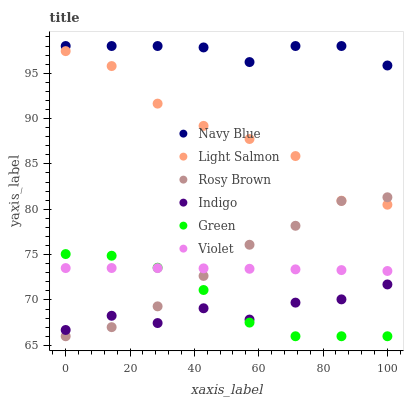Does Indigo have the minimum area under the curve?
Answer yes or no. Yes. Does Navy Blue have the maximum area under the curve?
Answer yes or no. Yes. Does Navy Blue have the minimum area under the curve?
Answer yes or no. No. Does Indigo have the maximum area under the curve?
Answer yes or no. No. Is Violet the smoothest?
Answer yes or no. Yes. Is Indigo the roughest?
Answer yes or no. Yes. Is Navy Blue the smoothest?
Answer yes or no. No. Is Navy Blue the roughest?
Answer yes or no. No. Does Rosy Brown have the lowest value?
Answer yes or no. Yes. Does Indigo have the lowest value?
Answer yes or no. No. Does Navy Blue have the highest value?
Answer yes or no. Yes. Does Indigo have the highest value?
Answer yes or no. No. Is Indigo less than Light Salmon?
Answer yes or no. Yes. Is Light Salmon greater than Violet?
Answer yes or no. Yes. Does Green intersect Indigo?
Answer yes or no. Yes. Is Green less than Indigo?
Answer yes or no. No. Is Green greater than Indigo?
Answer yes or no. No. Does Indigo intersect Light Salmon?
Answer yes or no. No. 